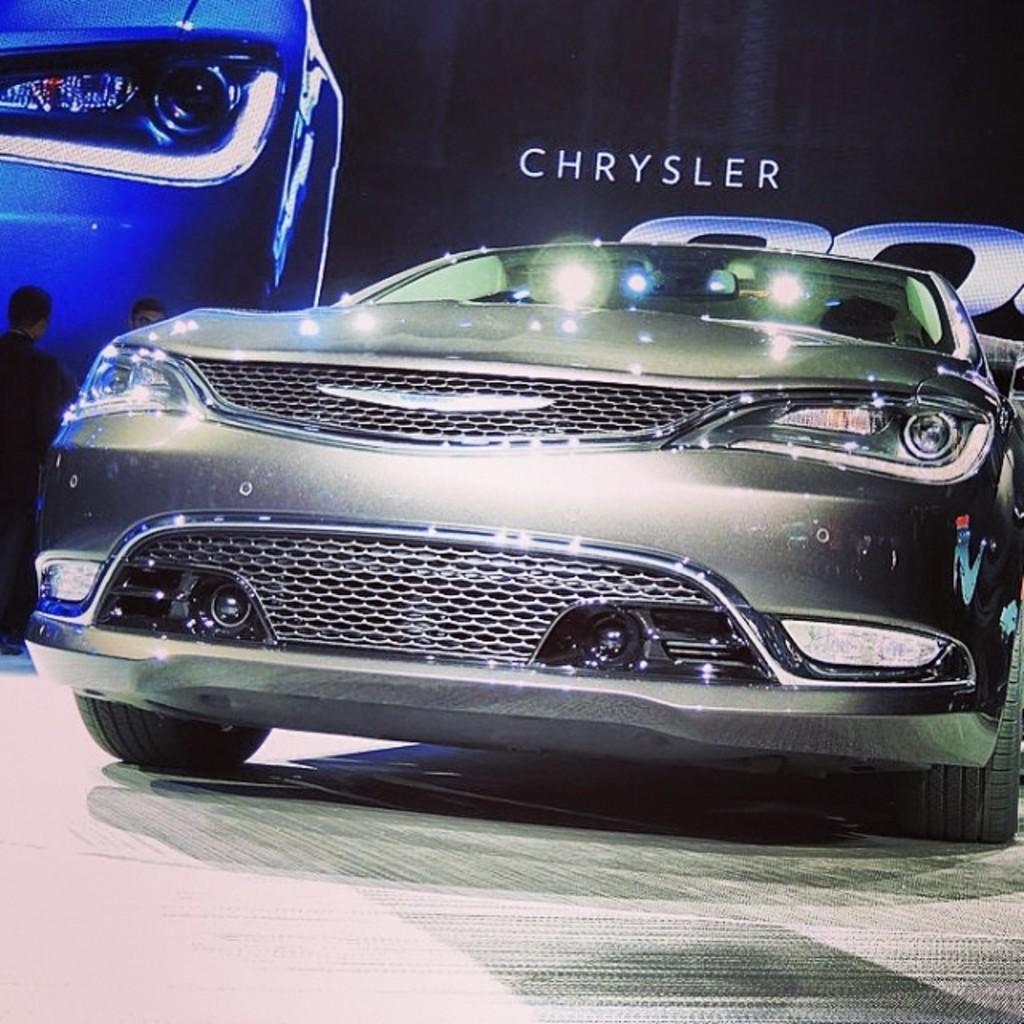What is the main subject of the image? There is a car in the image. Can you describe the people in the image? There are two people standing on the left side of the image. What else can be seen in the background of the image? There is written text visible on a board in the background of the image. How much does the string cost in the image? There is no string present in the image, so it cannot be determined how much it would cost. 